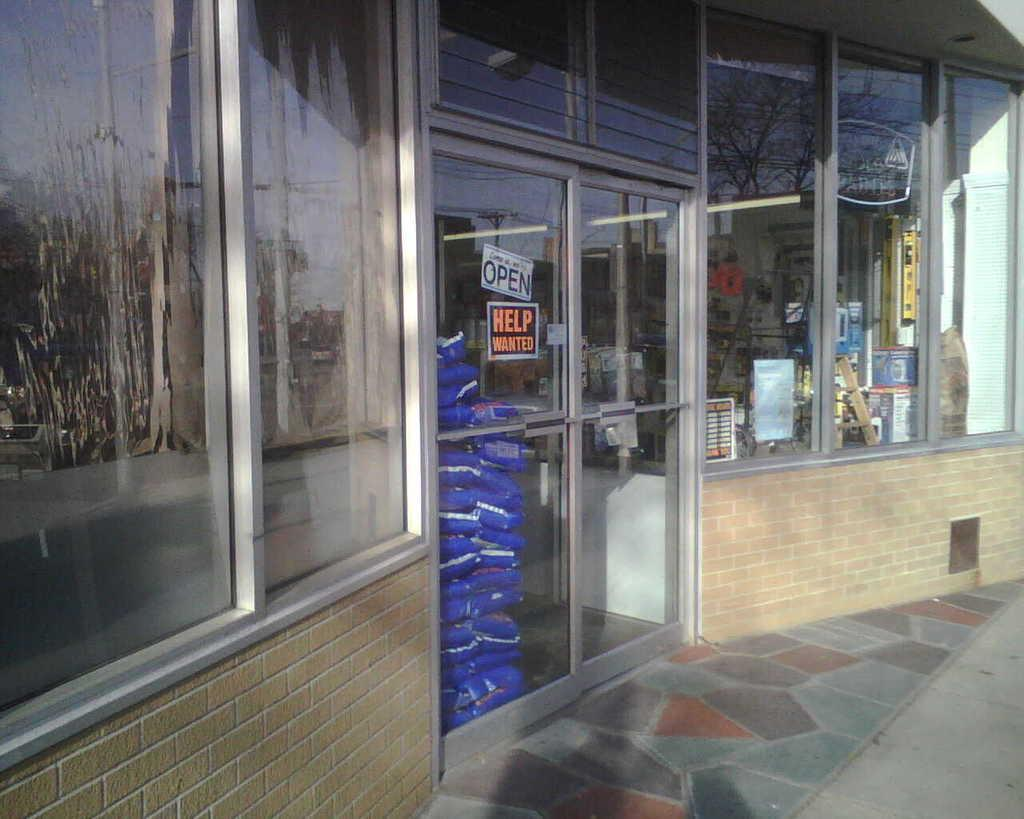<image>
Present a compact description of the photo's key features. A store that has a sign that says open and another that says help wanted. 